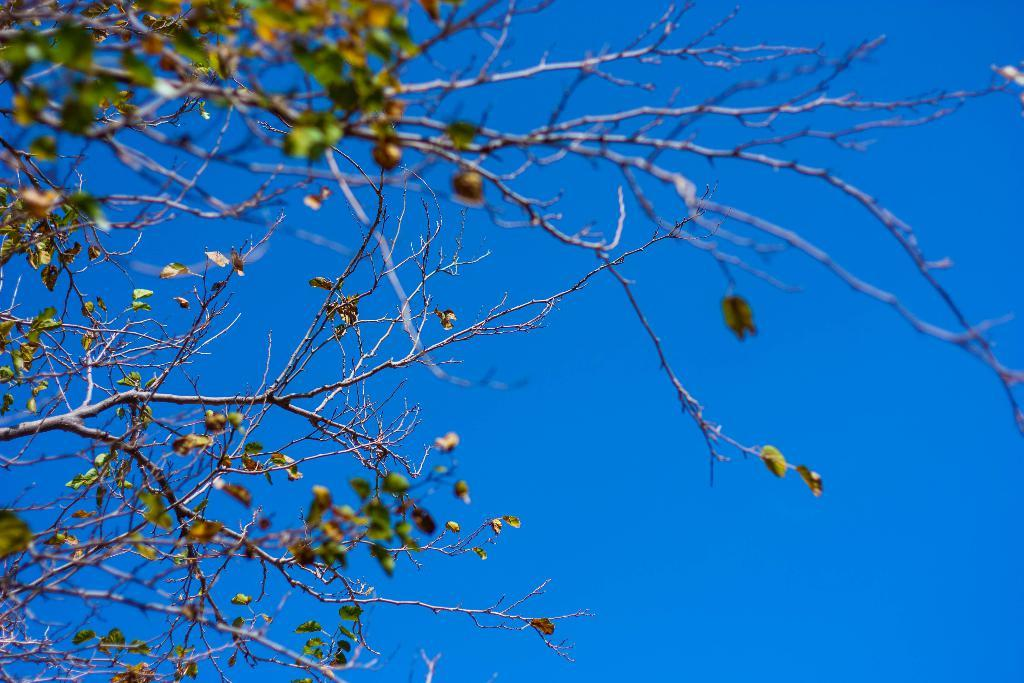What type of plant is present in the image? There is a tree with leaves in the image. What can be seen in the background of the image? The sky is visible in the background of the image. What type of veil is being worn by the tree in the image? There is no veil present in the image; it is a tree with leaves. Is there any evidence of a crime or a lawyer in the image? There is no mention of a crime or a lawyer in the image; it only features a tree with leaves and the sky in the background. 